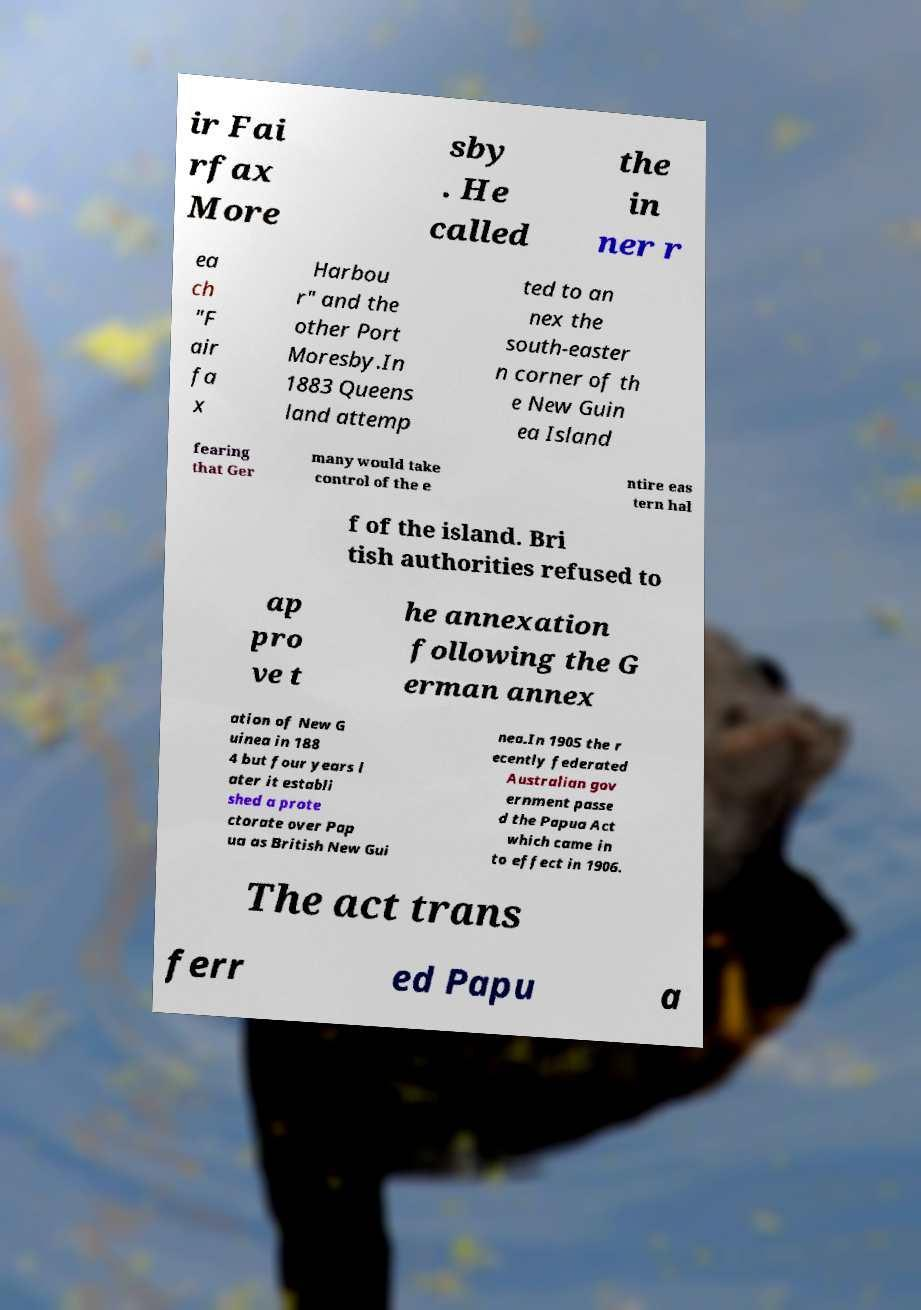Could you extract and type out the text from this image? ir Fai rfax More sby . He called the in ner r ea ch "F air fa x Harbou r" and the other Port Moresby.In 1883 Queens land attemp ted to an nex the south-easter n corner of th e New Guin ea Island fearing that Ger many would take control of the e ntire eas tern hal f of the island. Bri tish authorities refused to ap pro ve t he annexation following the G erman annex ation of New G uinea in 188 4 but four years l ater it establi shed a prote ctorate over Pap ua as British New Gui nea.In 1905 the r ecently federated Australian gov ernment passe d the Papua Act which came in to effect in 1906. The act trans ferr ed Papu a 